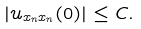<formula> <loc_0><loc_0><loc_500><loc_500>| u _ { x _ { n } x _ { n } } ( 0 ) | \leq C .</formula> 